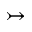Convert formula to latex. <formula><loc_0><loc_0><loc_500><loc_500>\rightarrow t a i l</formula> 